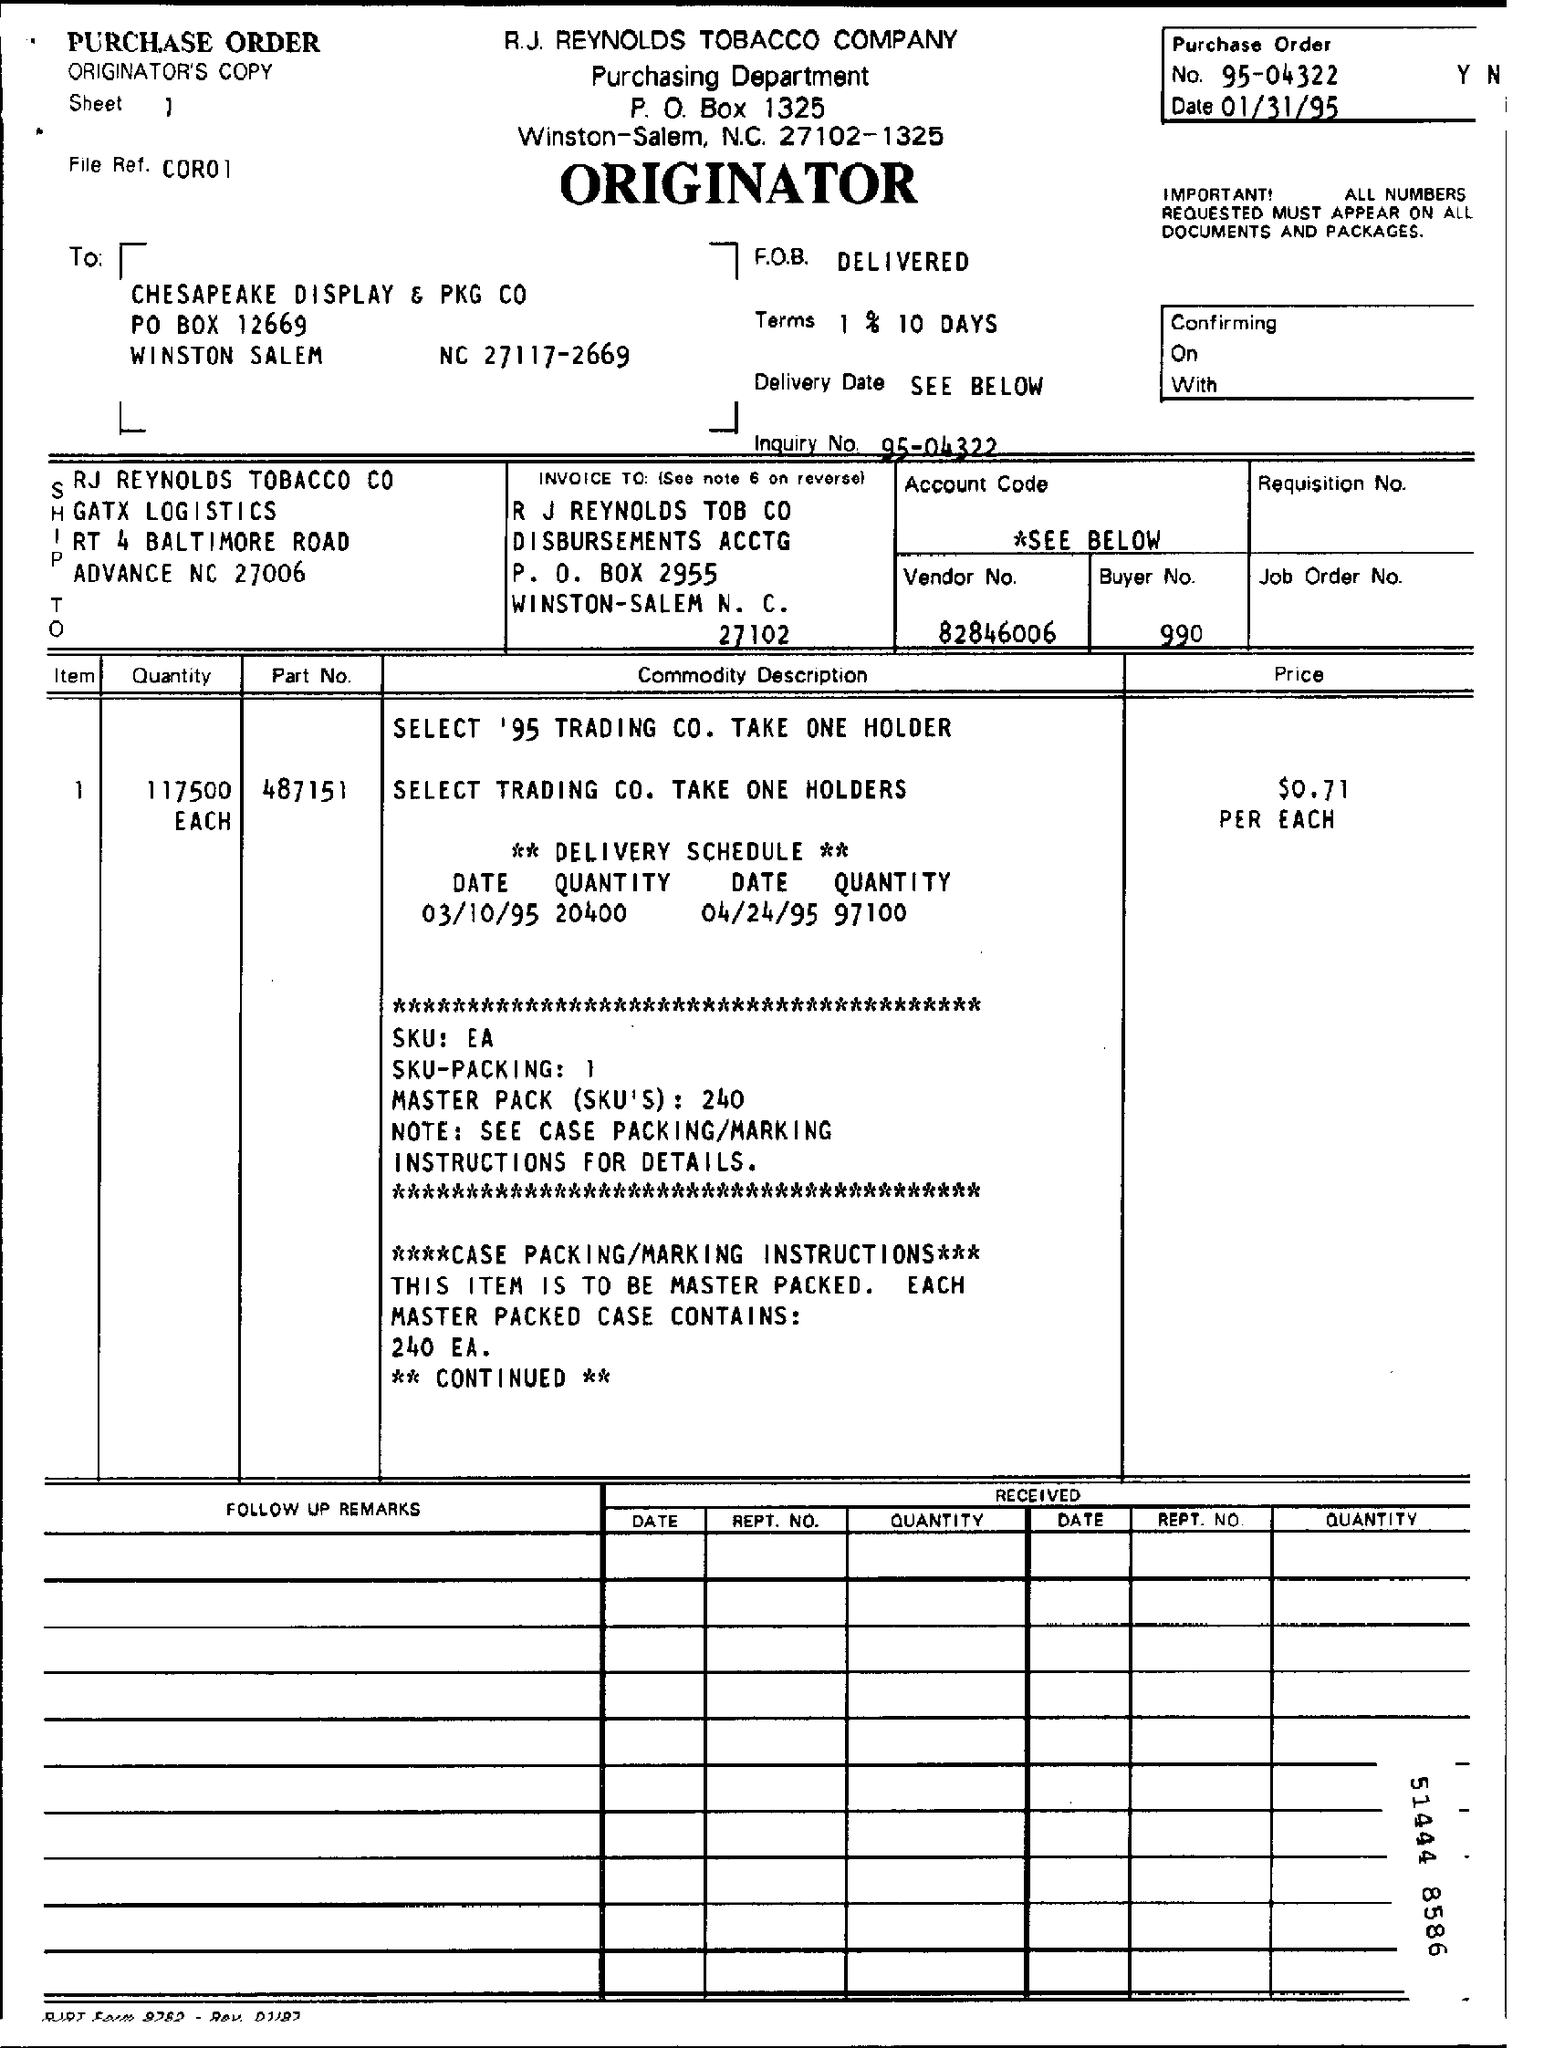What is the Purchase Order No.?
Provide a short and direct response. 95-04322. What is the Inquiry No.?
Offer a terse response. 95-04322. What is the Vendor No.?
Provide a succinct answer. 82846006. What is the Buyer No.?
Your response must be concise. 990. What is the Quantity?
Keep it short and to the point. 117500 Each. What is the Part No.?
Keep it short and to the point. 487151. What is the Price?
Your response must be concise. $0.71. 